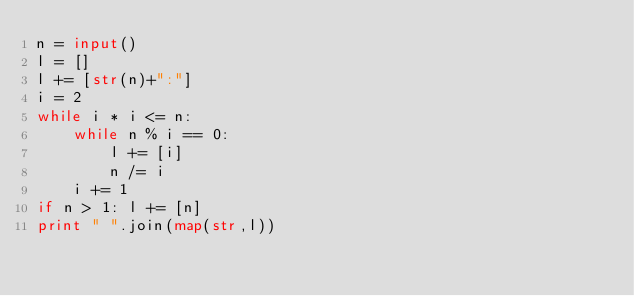<code> <loc_0><loc_0><loc_500><loc_500><_Python_>n = input()
l = []
l += [str(n)+":"]
i = 2
while i * i <= n:
    while n % i == 0:
        l += [i]
        n /= i
    i += 1
if n > 1: l += [n]
print " ".join(map(str,l))</code> 